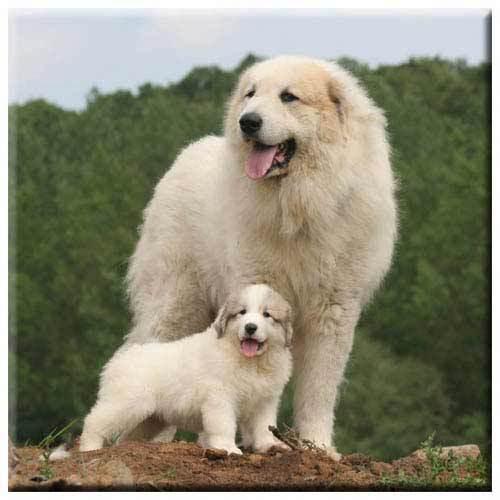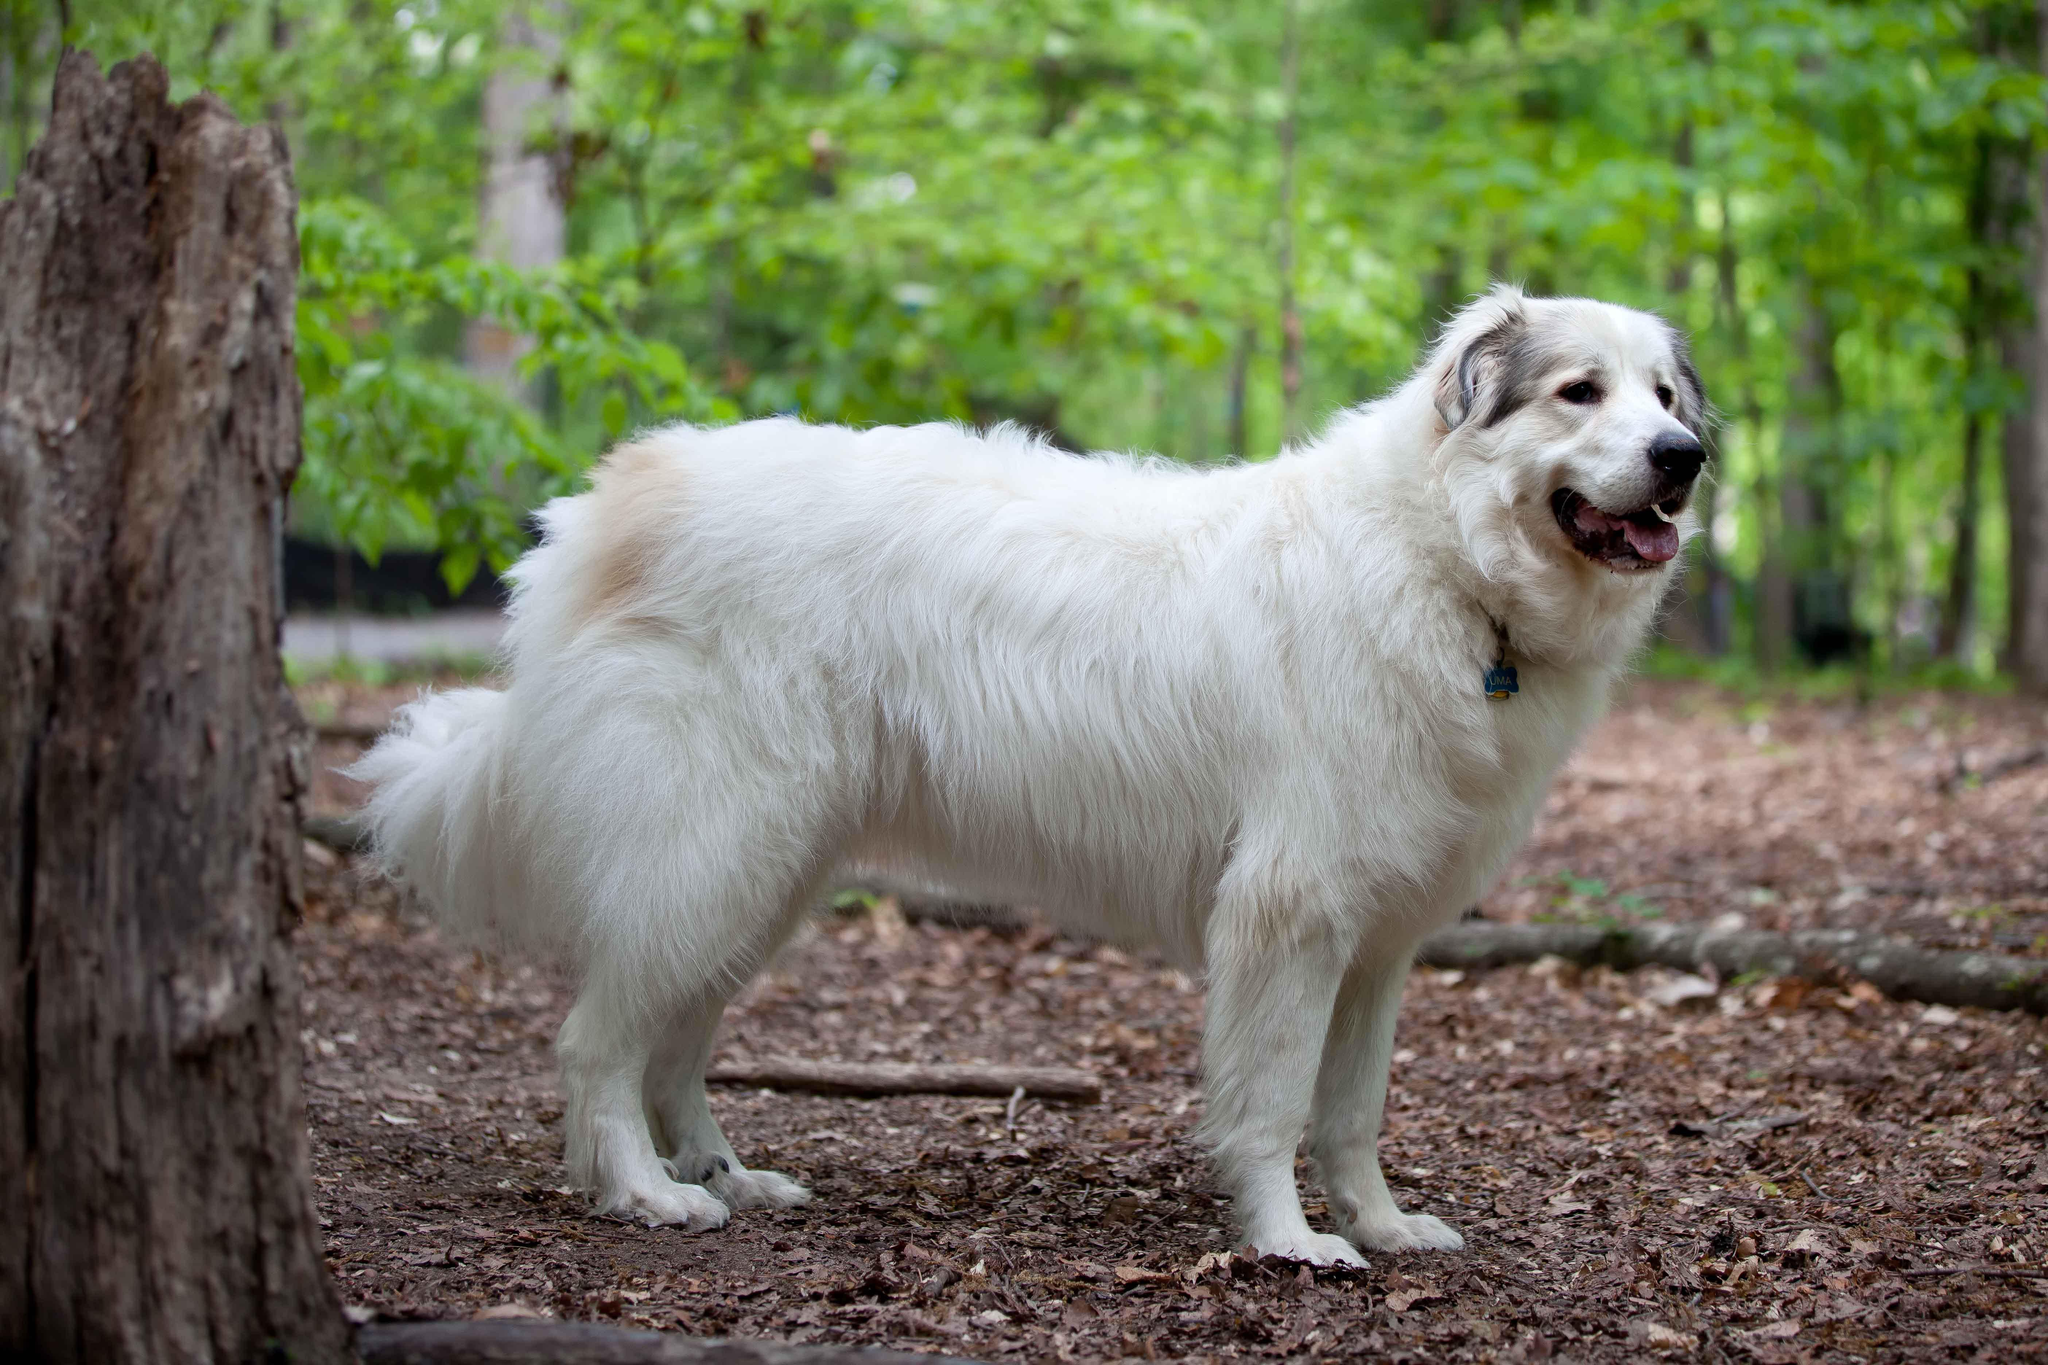The first image is the image on the left, the second image is the image on the right. Analyze the images presented: Is the assertion "An image contains at least two dogs." valid? Answer yes or no. Yes. The first image is the image on the left, the second image is the image on the right. For the images displayed, is the sentence "Two furry white dogs pose standing close together outdoors, in one image." factually correct? Answer yes or no. Yes. 